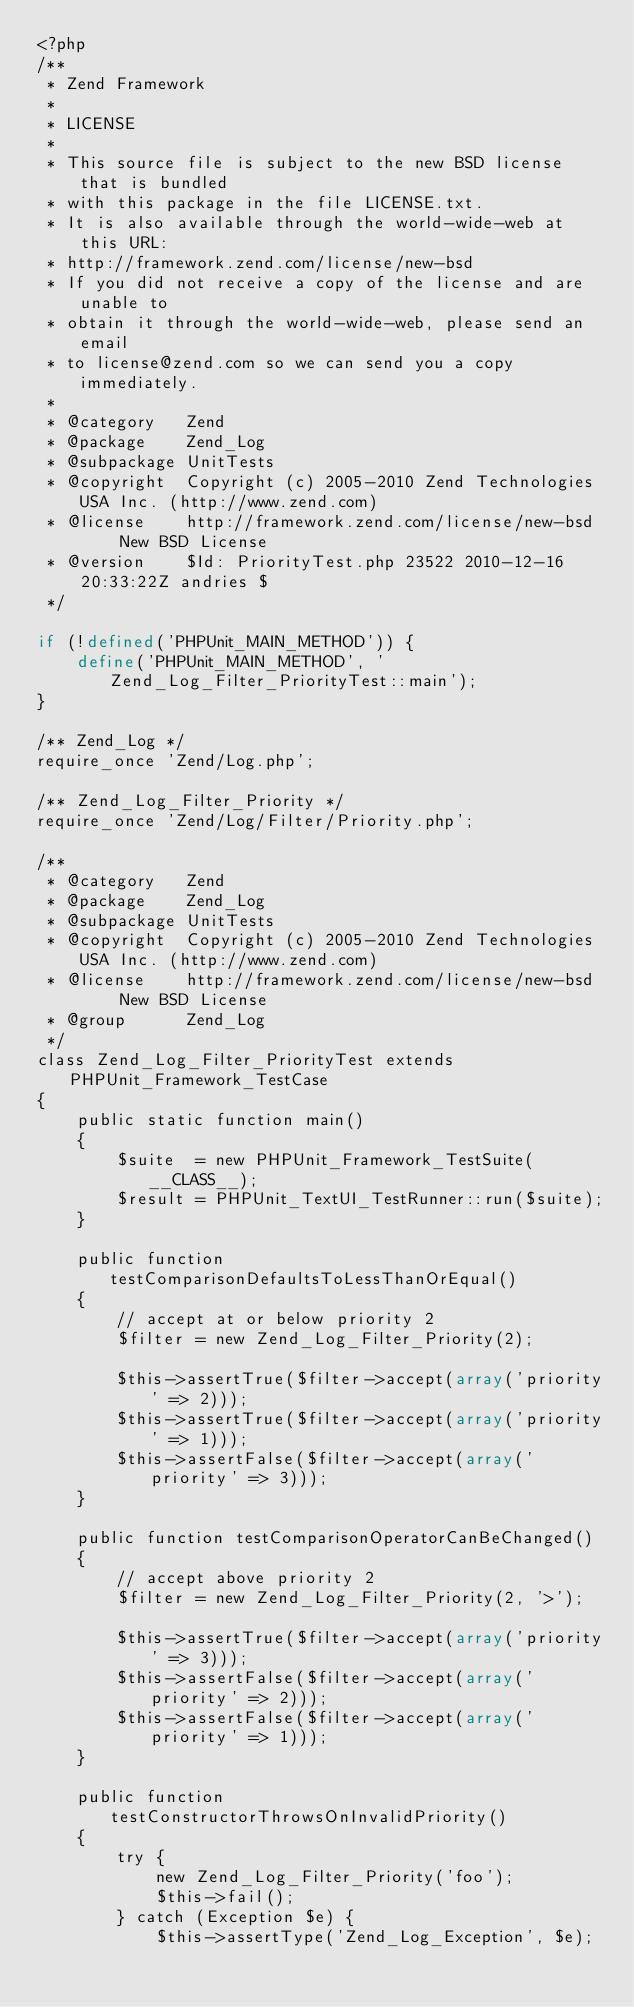<code> <loc_0><loc_0><loc_500><loc_500><_PHP_><?php
/**
 * Zend Framework
 *
 * LICENSE
 *
 * This source file is subject to the new BSD license that is bundled
 * with this package in the file LICENSE.txt.
 * It is also available through the world-wide-web at this URL:
 * http://framework.zend.com/license/new-bsd
 * If you did not receive a copy of the license and are unable to
 * obtain it through the world-wide-web, please send an email
 * to license@zend.com so we can send you a copy immediately.
 *
 * @category   Zend
 * @package    Zend_Log
 * @subpackage UnitTests
 * @copyright  Copyright (c) 2005-2010 Zend Technologies USA Inc. (http://www.zend.com)
 * @license    http://framework.zend.com/license/new-bsd     New BSD License
 * @version    $Id: PriorityTest.php 23522 2010-12-16 20:33:22Z andries $
 */

if (!defined('PHPUnit_MAIN_METHOD')) {
    define('PHPUnit_MAIN_METHOD', 'Zend_Log_Filter_PriorityTest::main');
}

/** Zend_Log */
require_once 'Zend/Log.php';

/** Zend_Log_Filter_Priority */
require_once 'Zend/Log/Filter/Priority.php';

/**
 * @category   Zend
 * @package    Zend_Log
 * @subpackage UnitTests
 * @copyright  Copyright (c) 2005-2010 Zend Technologies USA Inc. (http://www.zend.com)
 * @license    http://framework.zend.com/license/new-bsd     New BSD License
 * @group      Zend_Log
 */
class Zend_Log_Filter_PriorityTest extends PHPUnit_Framework_TestCase
{
    public static function main()
    {
        $suite  = new PHPUnit_Framework_TestSuite(__CLASS__);
        $result = PHPUnit_TextUI_TestRunner::run($suite);
    }

    public function testComparisonDefaultsToLessThanOrEqual()
    {
        // accept at or below priority 2
        $filter = new Zend_Log_Filter_Priority(2);

        $this->assertTrue($filter->accept(array('priority' => 2)));
        $this->assertTrue($filter->accept(array('priority' => 1)));
        $this->assertFalse($filter->accept(array('priority' => 3)));
    }

    public function testComparisonOperatorCanBeChanged()
    {
        // accept above priority 2
        $filter = new Zend_Log_Filter_Priority(2, '>');

        $this->assertTrue($filter->accept(array('priority' => 3)));
        $this->assertFalse($filter->accept(array('priority' => 2)));
        $this->assertFalse($filter->accept(array('priority' => 1)));
    }

    public function testConstructorThrowsOnInvalidPriority()
    {
        try {
            new Zend_Log_Filter_Priority('foo');
            $this->fail();
        } catch (Exception $e) {
            $this->assertType('Zend_Log_Exception', $e);</code> 